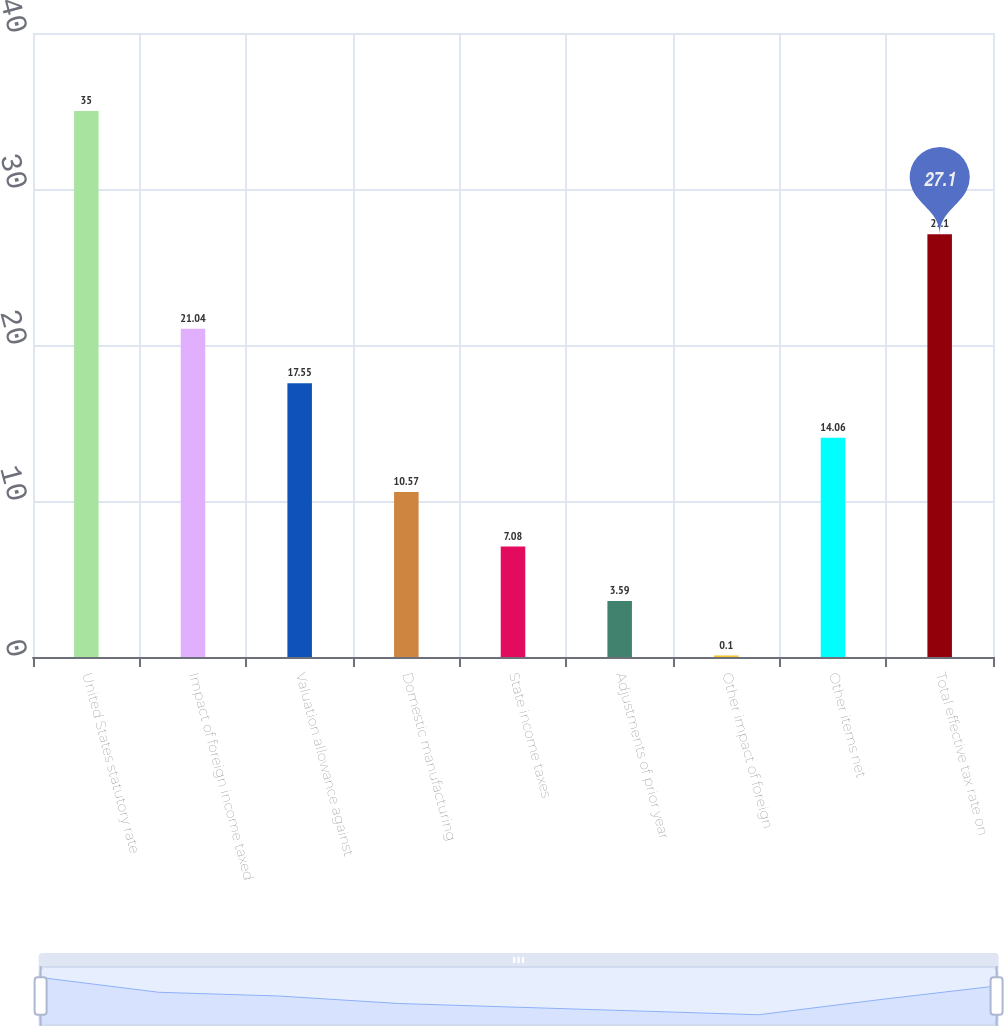Convert chart to OTSL. <chart><loc_0><loc_0><loc_500><loc_500><bar_chart><fcel>United States statutory rate<fcel>Impact of foreign income taxed<fcel>Valuation allowance against<fcel>Domestic manufacturing<fcel>State income taxes<fcel>Adjustments of prior year<fcel>Other impact of foreign<fcel>Other items net<fcel>Total effective tax rate on<nl><fcel>35<fcel>21.04<fcel>17.55<fcel>10.57<fcel>7.08<fcel>3.59<fcel>0.1<fcel>14.06<fcel>27.1<nl></chart> 